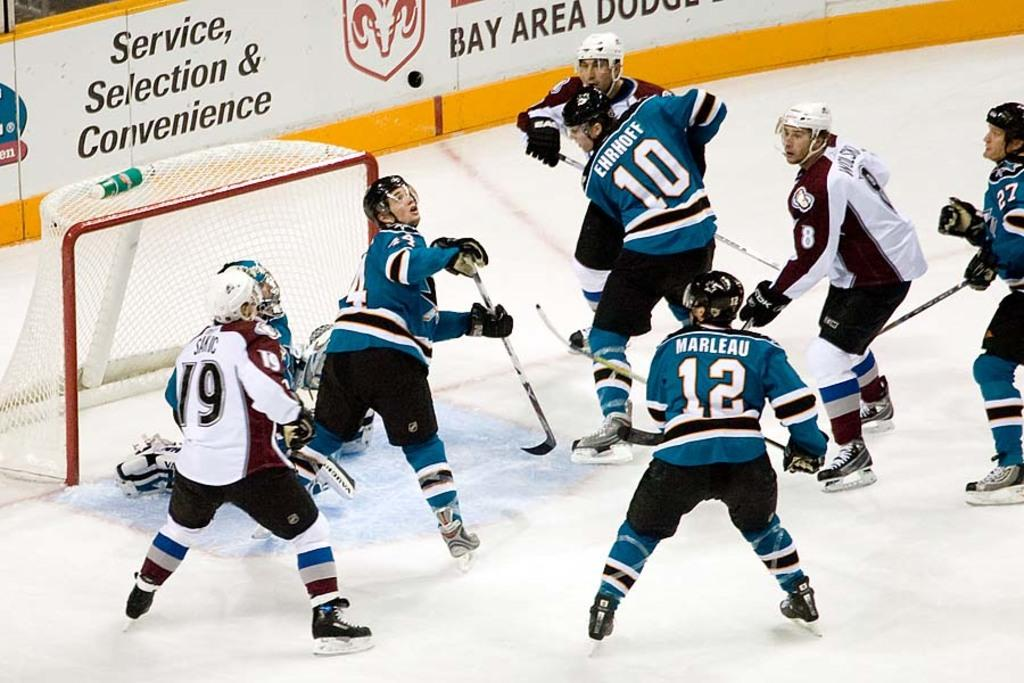<image>
Summarize the visual content of the image. Soccer players playing on ice with words that say "Service, Selection, and Convenience in the back. 